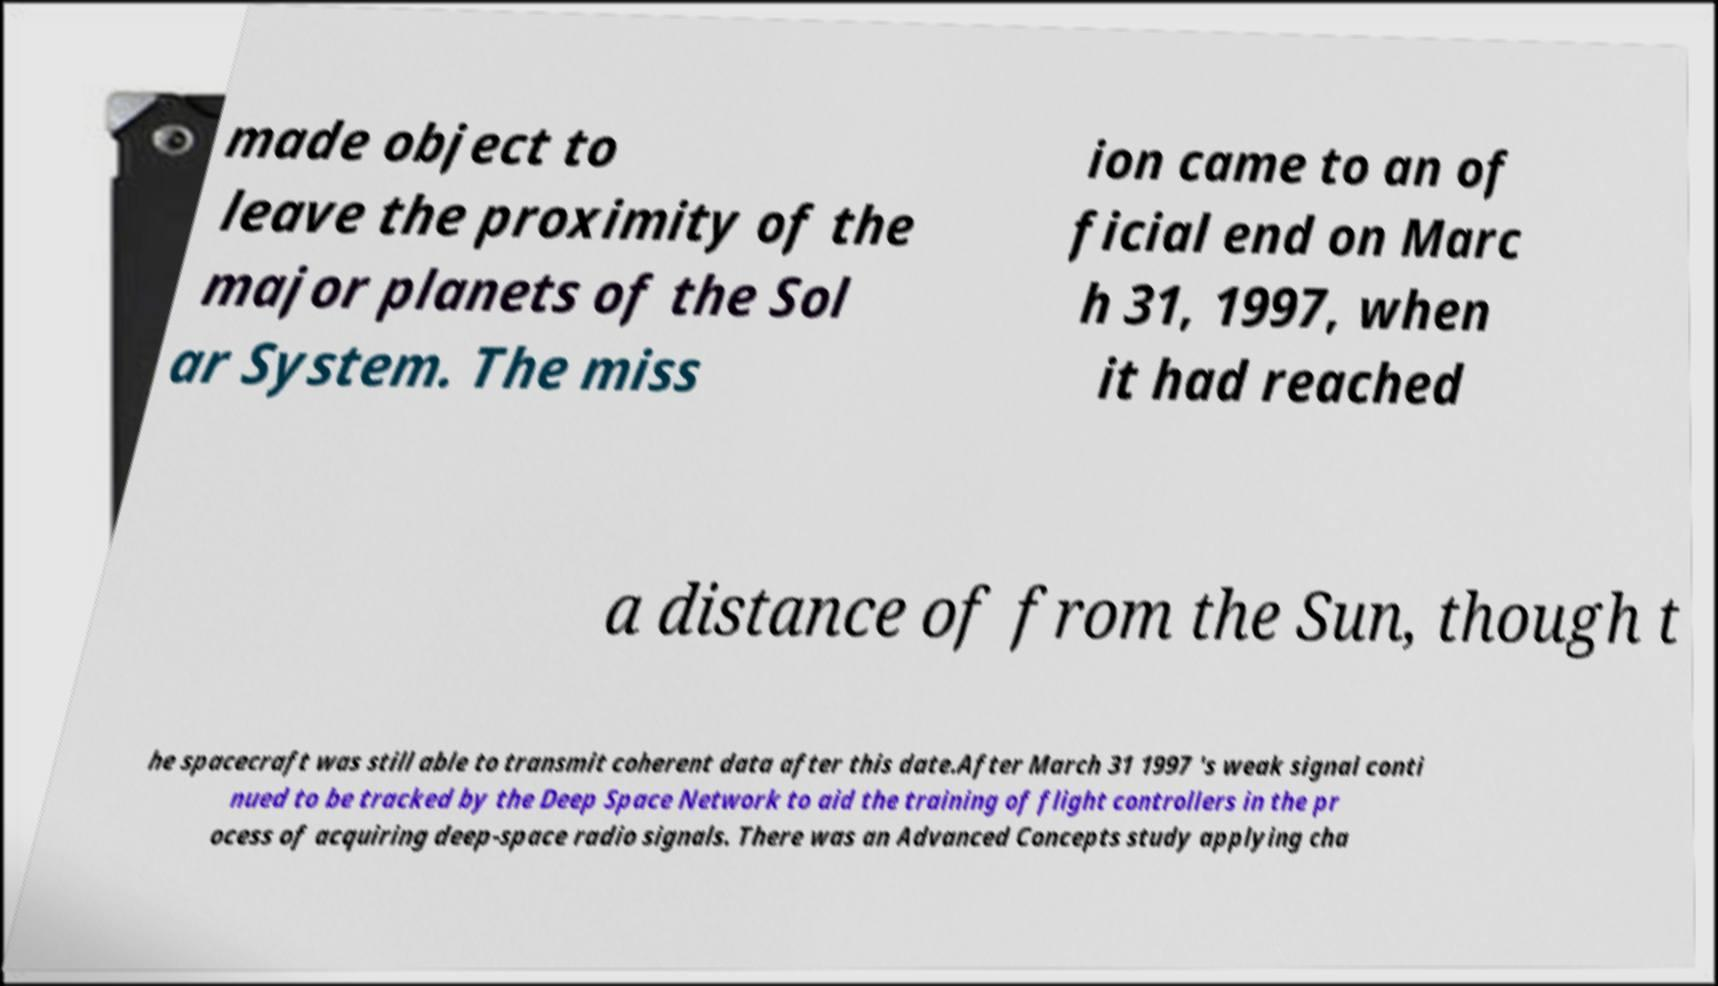Can you accurately transcribe the text from the provided image for me? made object to leave the proximity of the major planets of the Sol ar System. The miss ion came to an of ficial end on Marc h 31, 1997, when it had reached a distance of from the Sun, though t he spacecraft was still able to transmit coherent data after this date.After March 31 1997 's weak signal conti nued to be tracked by the Deep Space Network to aid the training of flight controllers in the pr ocess of acquiring deep-space radio signals. There was an Advanced Concepts study applying cha 